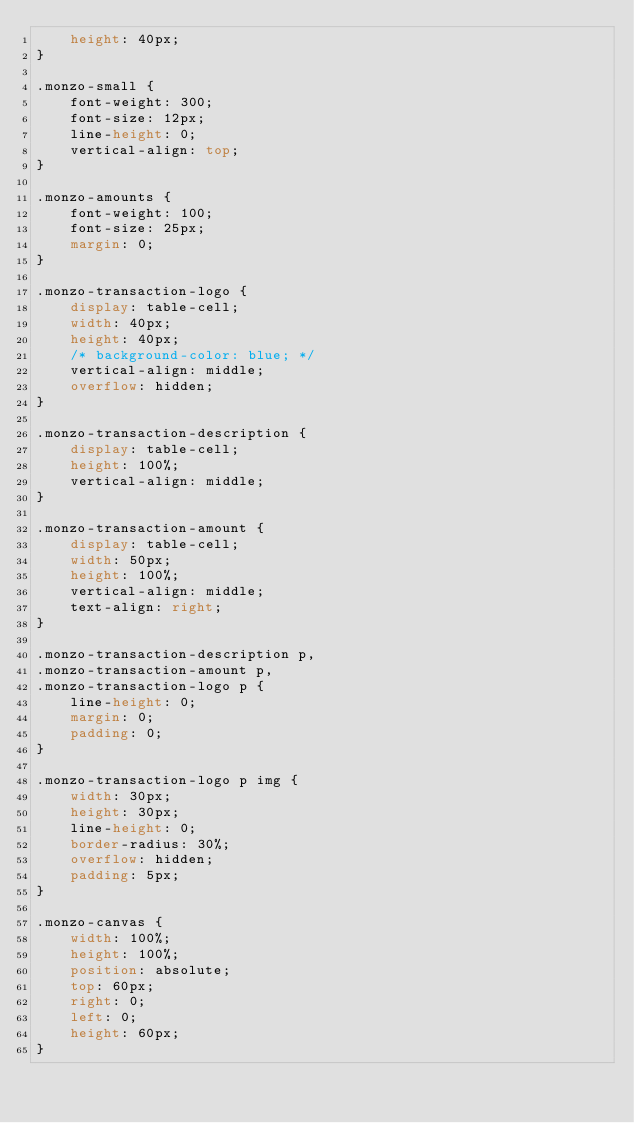<code> <loc_0><loc_0><loc_500><loc_500><_CSS_>    height: 40px;
}

.monzo-small {
    font-weight: 300;
    font-size: 12px;
    line-height: 0;
    vertical-align: top;
}

.monzo-amounts {
    font-weight: 100;
    font-size: 25px;
    margin: 0;
}

.monzo-transaction-logo {
    display: table-cell;
    width: 40px;
    height: 40px;
    /* background-color: blue; */
    vertical-align: middle;
    overflow: hidden;
}

.monzo-transaction-description {
    display: table-cell;
    height: 100%;
    vertical-align: middle;
}

.monzo-transaction-amount {
    display: table-cell;
    width: 50px;
    height: 100%;
    vertical-align: middle;
    text-align: right;
}

.monzo-transaction-description p,
.monzo-transaction-amount p,
.monzo-transaction-logo p {
    line-height: 0;
    margin: 0;
    padding: 0;
}

.monzo-transaction-logo p img {
    width: 30px;
    height: 30px;
    line-height: 0;
    border-radius: 30%;
    overflow: hidden;
    padding: 5px;
}

.monzo-canvas {
    width: 100%;
    height: 100%;
    position: absolute;
    top: 60px;
    right: 0;
    left: 0;
    height: 60px;
}
</code> 